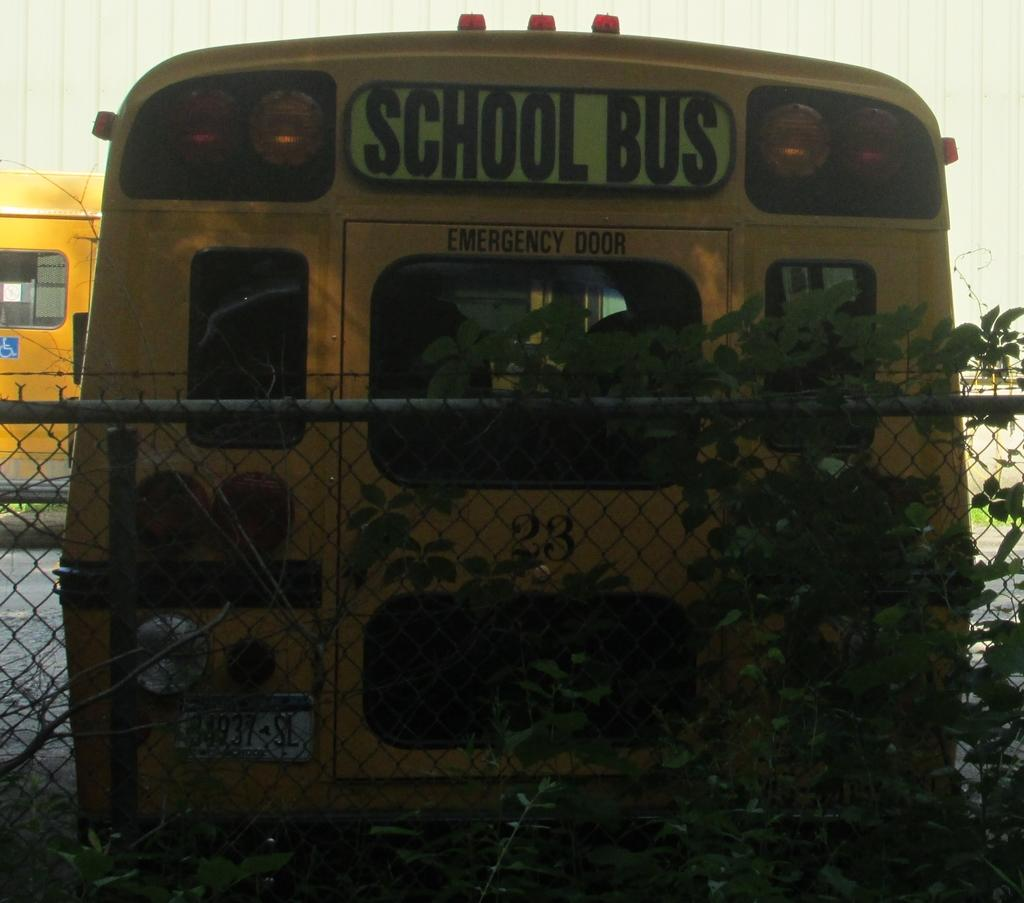<image>
Write a terse but informative summary of the picture. The back of a school bus with the Emergency Door sign visible is backed up to a chain link fence. 